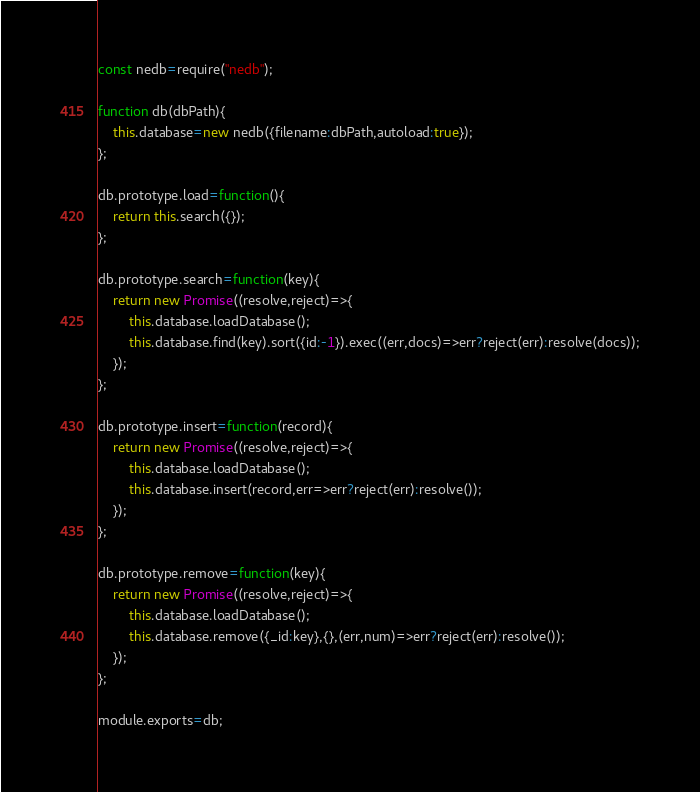<code> <loc_0><loc_0><loc_500><loc_500><_JavaScript_>const nedb=require("nedb");

function db(dbPath){
	this.database=new nedb({filename:dbPath,autoload:true});
};

db.prototype.load=function(){
	return this.search({});
};

db.prototype.search=function(key){
	return new Promise((resolve,reject)=>{
		this.database.loadDatabase();
		this.database.find(key).sort({id:-1}).exec((err,docs)=>err?reject(err):resolve(docs));
	});
};

db.prototype.insert=function(record){
	return new Promise((resolve,reject)=>{
		this.database.loadDatabase();
		this.database.insert(record,err=>err?reject(err):resolve());
	});
};

db.prototype.remove=function(key){
	return new Promise((resolve,reject)=>{
		this.database.loadDatabase();
		this.database.remove({_id:key},{},(err,num)=>err?reject(err):resolve());
	});
};

module.exports=db;
</code> 